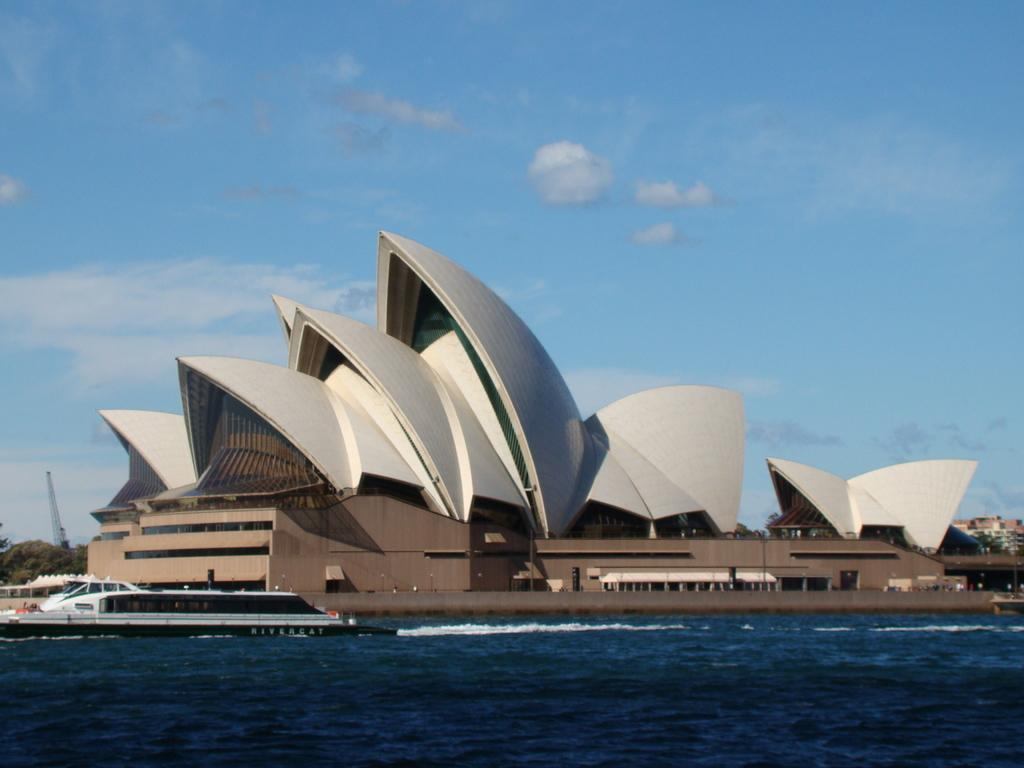What is the main subject of the image? The main subject of the image is a ship. Where is the ship located in the image? The ship is on the water. What can be seen in the background of the image? There are buildings, trees, a crane, and clouds visible in the background of the image. What type of oatmeal is being served on the ship in the image? There is no oatmeal present in the image; it features a ship on the water with a background of buildings, trees, a crane, and clouds. 